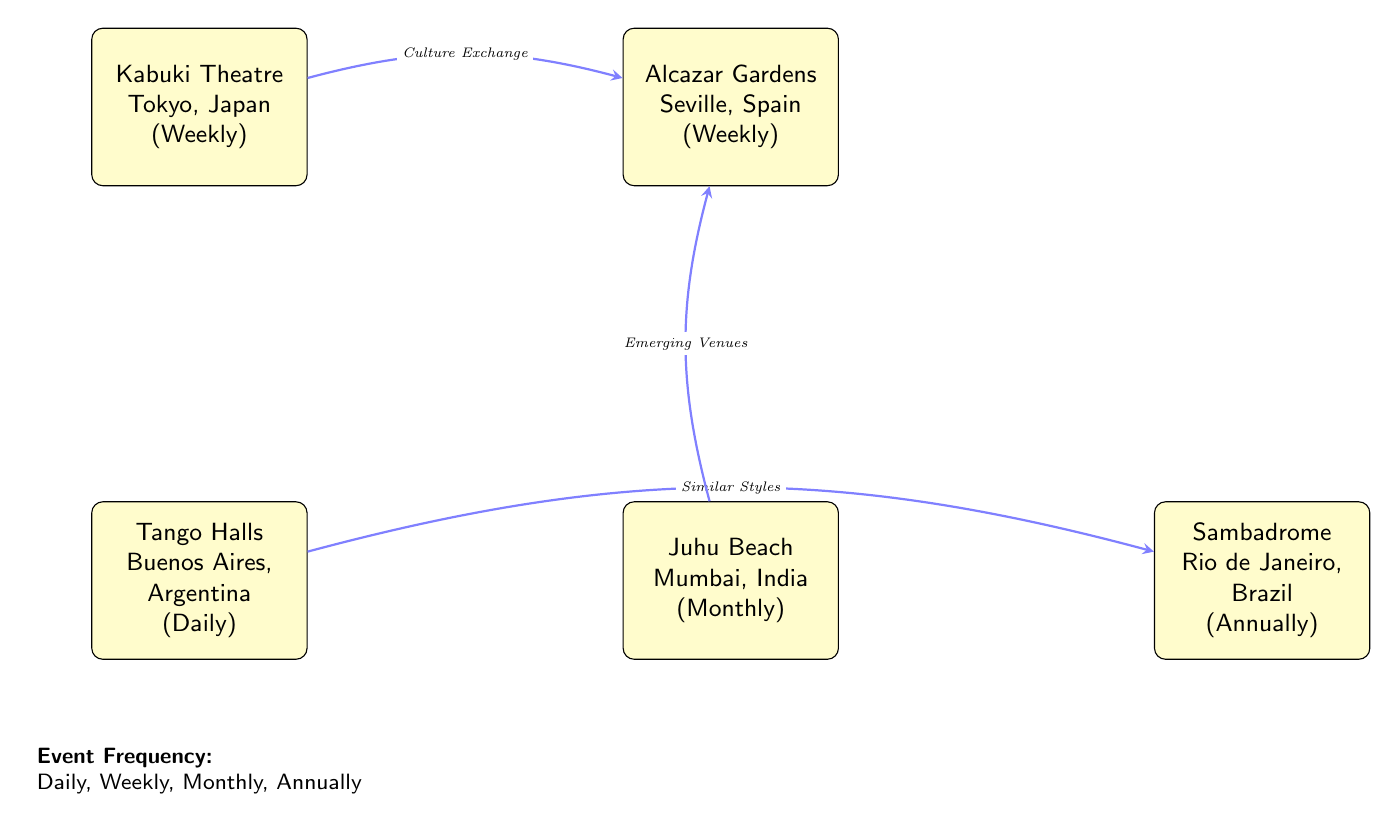What dance performance venue in Japan is mapped in the diagram? The diagram shows "Kabuki Theatre" as the dance performance venue located in Tokyo, Japan. It highlights its event frequency as "Weekly."
Answer: Kabuki Theatre How often does the Tango Halls venue host performances? The Tango Halls venue in Buenos Aires, Argentina is indicated to have daily performances.
Answer: Daily Which two venues have a weekly performance frequency? The diagram lists both "Kabuki Theatre" in Japan and "Alcazar Gardens" in Spain with a "Weekly" performance frequency.
Answer: Kabuki Theatre, Alcazar Gardens What is the event frequency at Juhu Beach in India? The diagram states that Juhu Beach in Mumbai, India hosts dance performances on a monthly basis, as indicated next to the venue name.
Answer: Monthly Which venue has an annual performance frequency? The diagram identifies "Sambadrome" in Rio de Janeiro, Brazil as the venue with an "Annually" event frequency.
Answer: Sambadrome How many venues are connected to the Alcazar Gardens in Spain by arrows? The diagram shows that there are two connected venues, "Kabuki Theatre" and "Juhu Beach," both having directed arrows leading to "Alcazar Gardens."
Answer: 2 What type of connection exists between Argentina and Brazil in this diagram? The connection between Argentina's Tango Halls and Brazil's Sambadrome is labeled as "Similar Styles," indicating a relationship based on cultural characteristics of the dance styles.
Answer: Similar Styles Which venue is mapped below the Kabuki Theatre? The diagram displays "Tango Halls" located below Kabuki Theatre, indicating its position on the map relative to Japan.
Answer: Tango Halls What does the arrow labeled "Emerging Venues" connect? The "Emerging Venues" arrow connects Juhu Beach in India to Alcazar Gardens in Spain, highlighting a relationship between dance performance venues.
Answer: Juhu Beach and Alcazar Gardens 